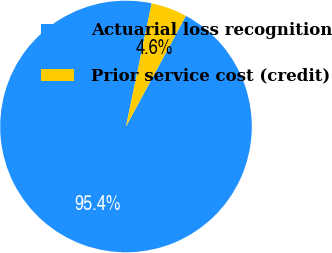Convert chart to OTSL. <chart><loc_0><loc_0><loc_500><loc_500><pie_chart><fcel>Actuarial loss recognition<fcel>Prior service cost (credit)<nl><fcel>95.37%<fcel>4.63%<nl></chart> 